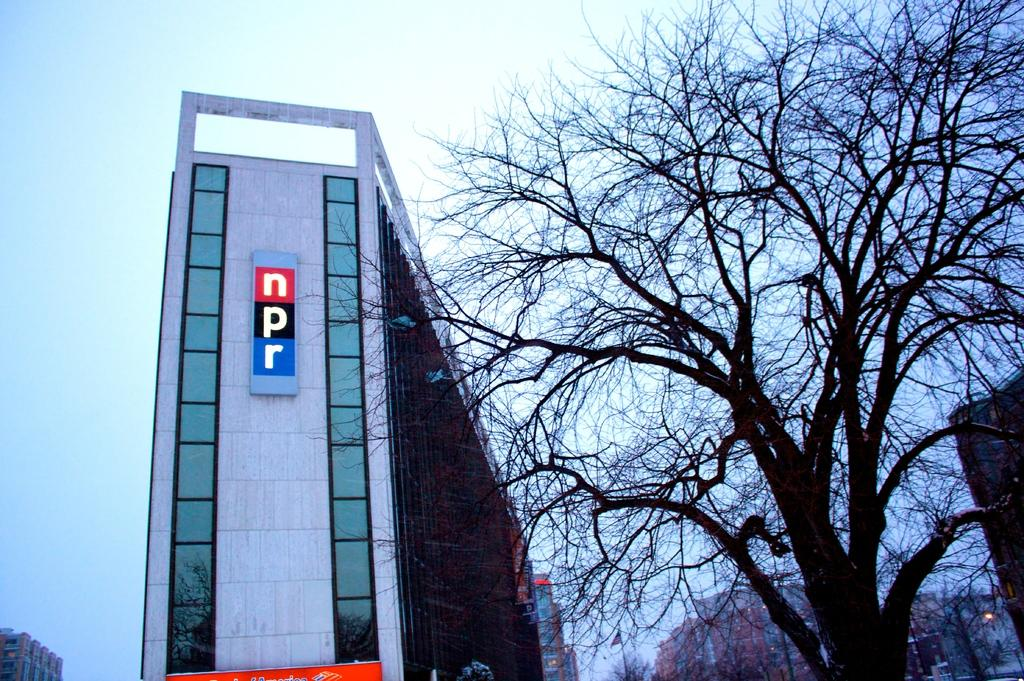What type of vegetation is on the right side of the image? There are trees on the right side of the image. What structures are located on the right side of the image? There are buildings on the right side of the image. What can be seen on the right side of the image that might provide illumination? There is a light on the right side of the image. What type of structures can be seen in the center of the image? There are buildings in the center of the image. What type of structure is located on the left side of the image? There is a building on the left side of the image. How would you describe the weather based on the sky in the image? The sky is cloudy in the image. How many pizzas are being served in the bath in the image? There are no pizzas or baths present in the image. What type of hand can be seen interacting with the trees on the right side of the image? There are no hands visible in the image; only trees, buildings, and a light are present. 